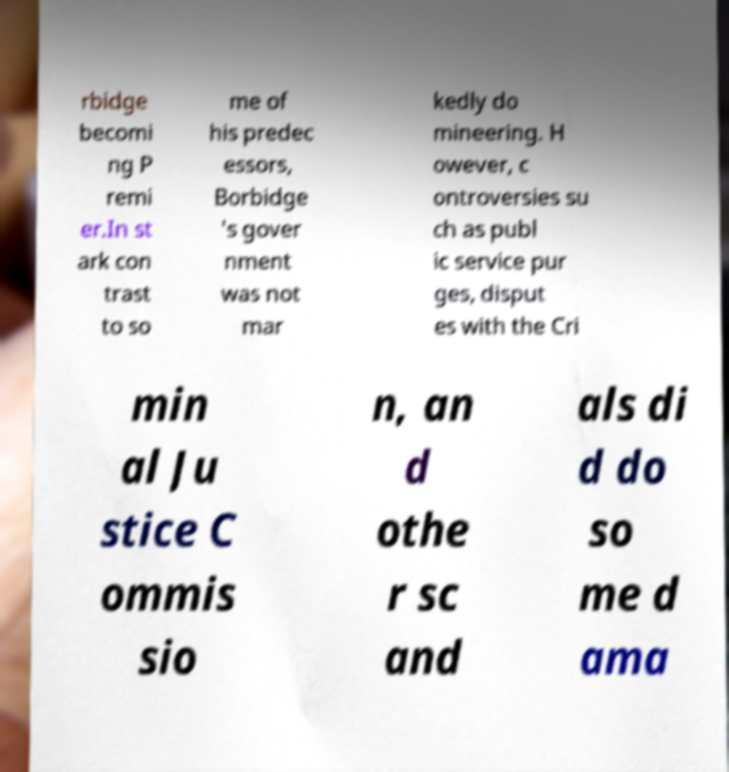Can you accurately transcribe the text from the provided image for me? rbidge becomi ng P remi er.In st ark con trast to so me of his predec essors, Borbidge 's gover nment was not mar kedly do mineering. H owever, c ontroversies su ch as publ ic service pur ges, disput es with the Cri min al Ju stice C ommis sio n, an d othe r sc and als di d do so me d ama 